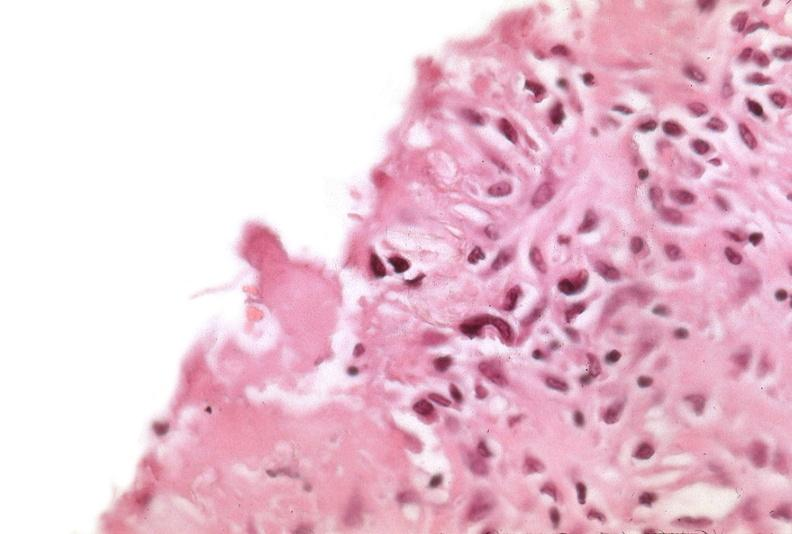was vasculitis due to rocky mountain used to sclerose emphysematous lung, alpha-1 antitrypsin deficiency?
Answer the question using a single word or phrase. No 